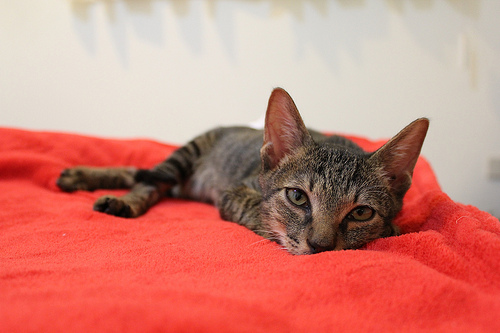<image>
Is the cat in the blanket? No. The cat is not contained within the blanket. These objects have a different spatial relationship. 